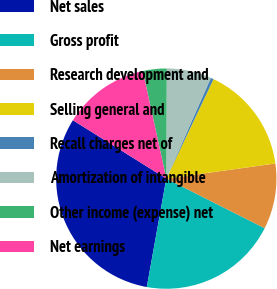Convert chart to OTSL. <chart><loc_0><loc_0><loc_500><loc_500><pie_chart><fcel>Net sales<fcel>Gross profit<fcel>Research development and<fcel>Selling general and<fcel>Recall charges net of<fcel>Amortization of intangible<fcel>Other income (expense) net<fcel>Net earnings<nl><fcel>31.06%<fcel>20.4%<fcel>9.62%<fcel>15.75%<fcel>0.43%<fcel>6.56%<fcel>3.49%<fcel>12.68%<nl></chart> 